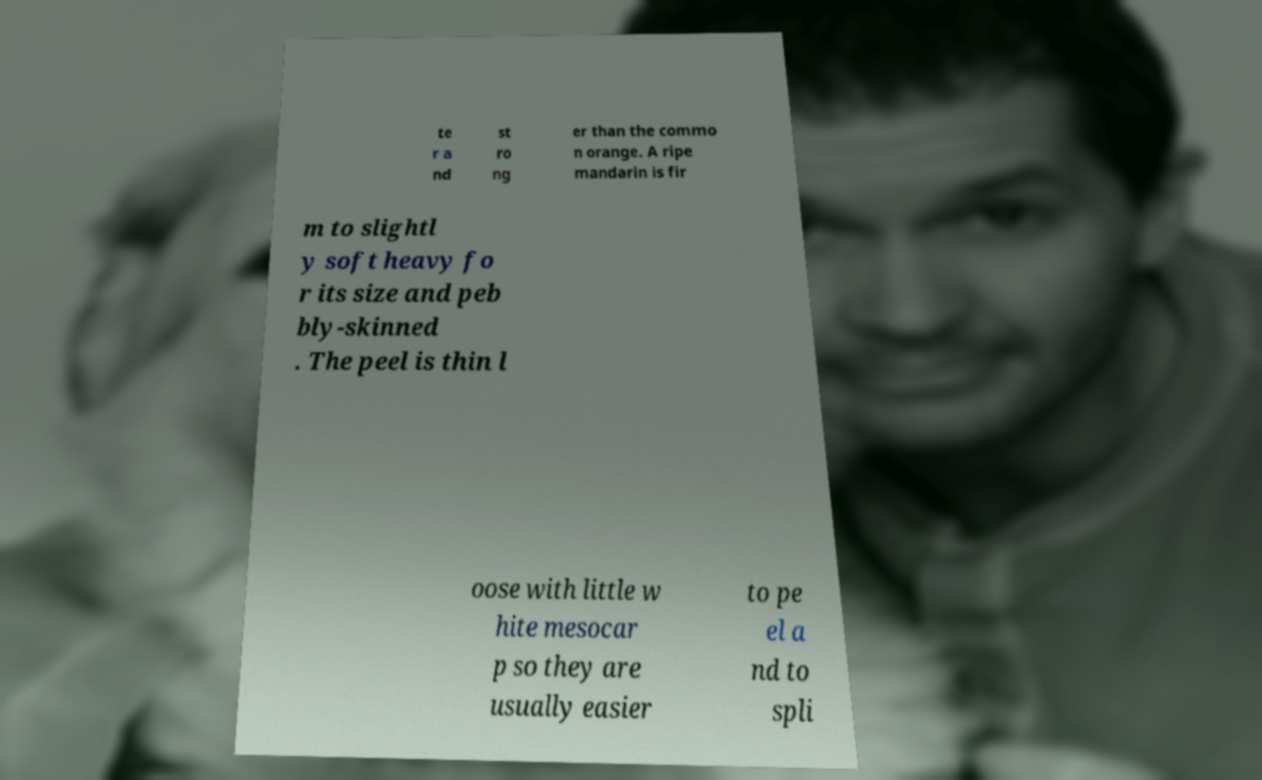Can you accurately transcribe the text from the provided image for me? te r a nd st ro ng er than the commo n orange. A ripe mandarin is fir m to slightl y soft heavy fo r its size and peb bly-skinned . The peel is thin l oose with little w hite mesocar p so they are usually easier to pe el a nd to spli 